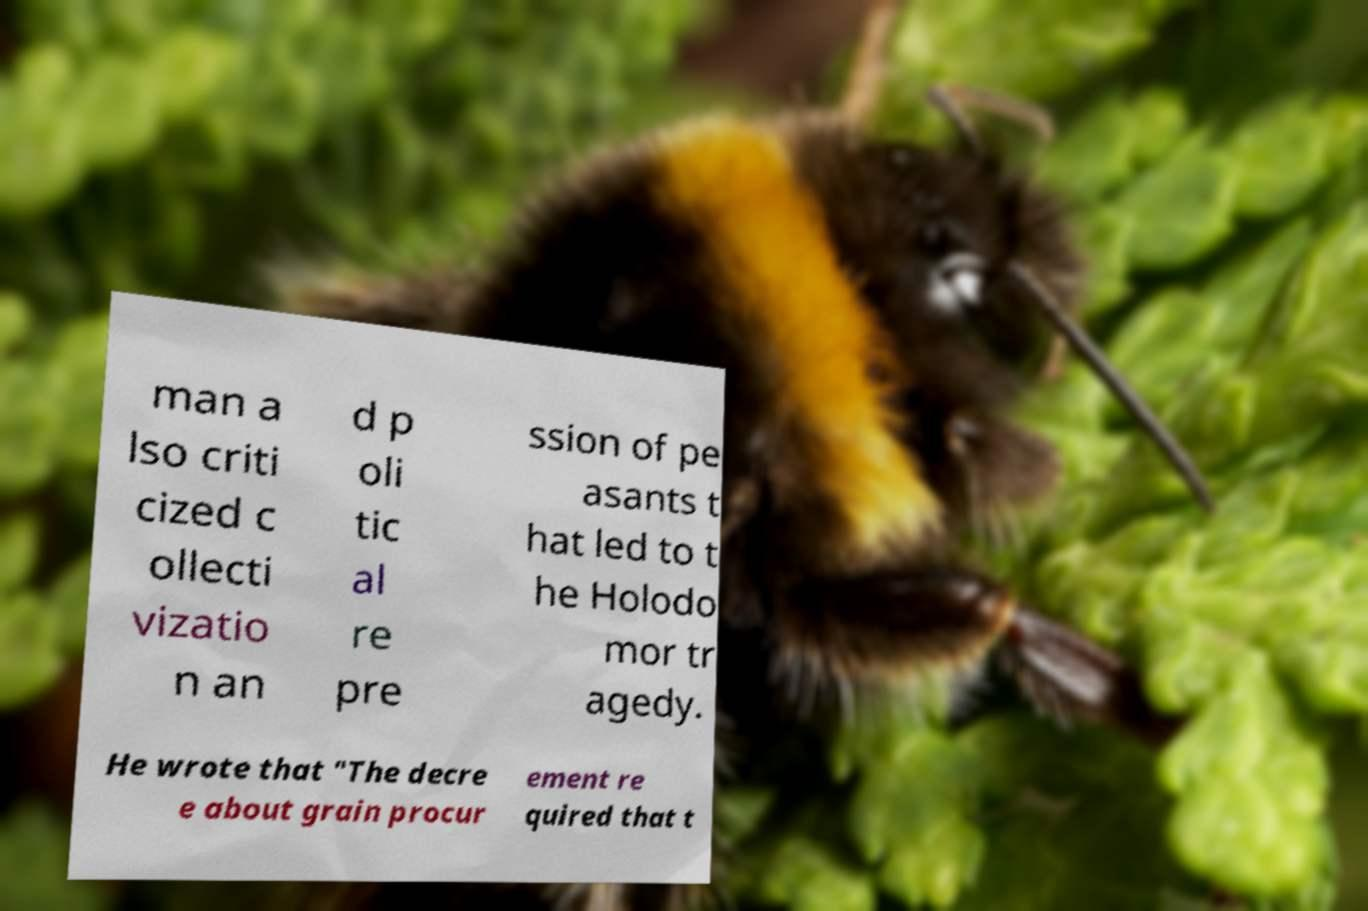I need the written content from this picture converted into text. Can you do that? man a lso criti cized c ollecti vizatio n an d p oli tic al re pre ssion of pe asants t hat led to t he Holodo mor tr agedy. He wrote that "The decre e about grain procur ement re quired that t 